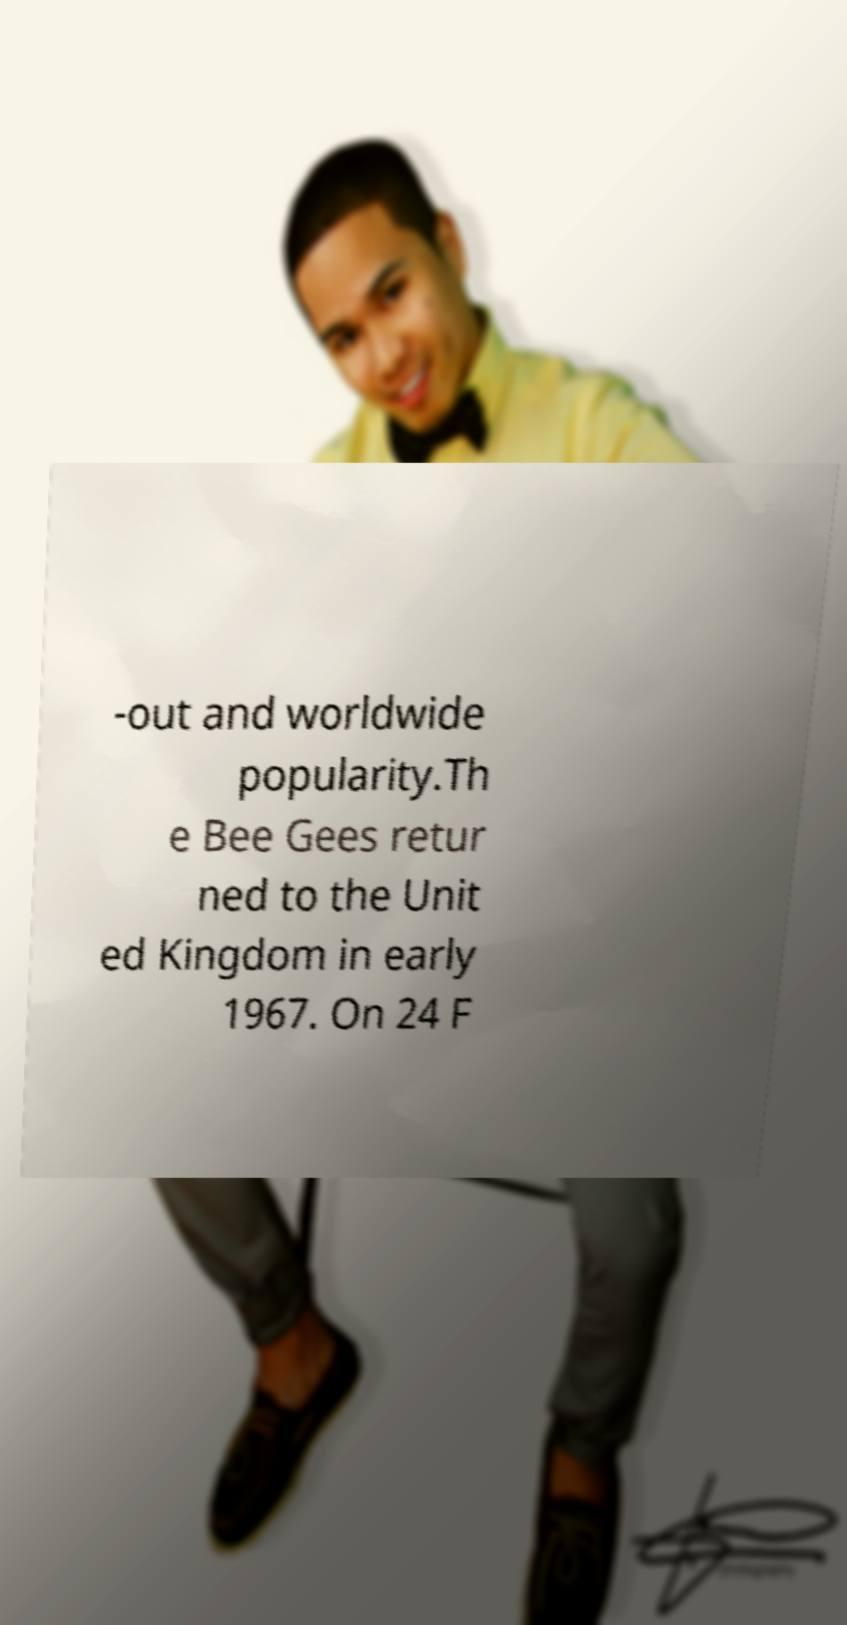Can you read and provide the text displayed in the image?This photo seems to have some interesting text. Can you extract and type it out for me? -out and worldwide popularity.Th e Bee Gees retur ned to the Unit ed Kingdom in early 1967. On 24 F 